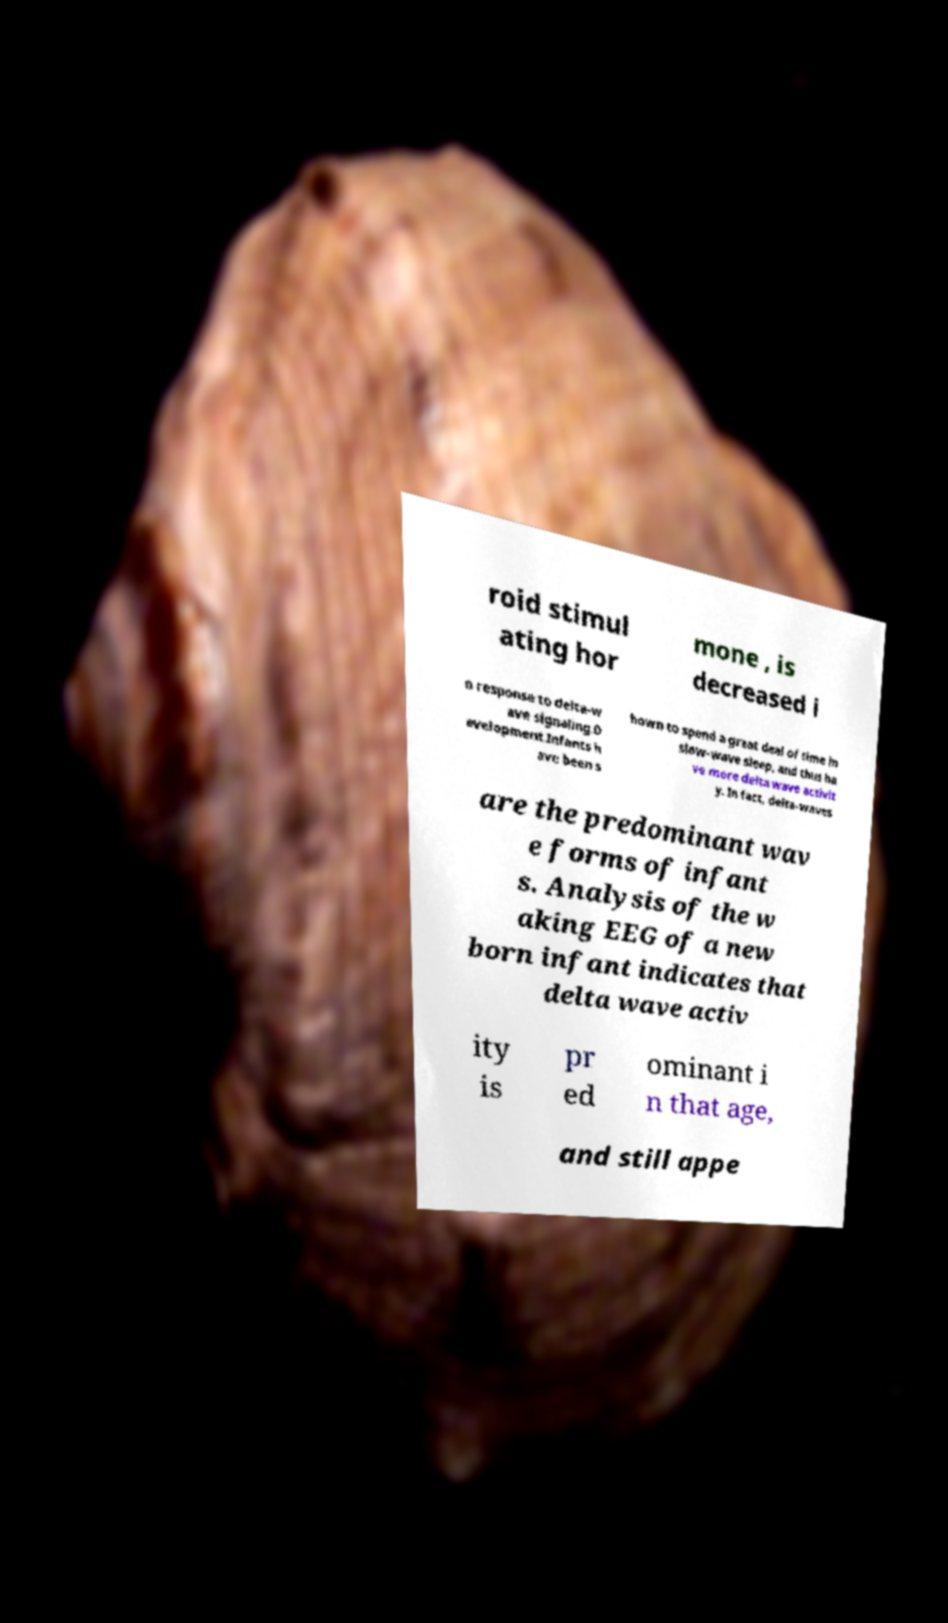There's text embedded in this image that I need extracted. Can you transcribe it verbatim? roid stimul ating hor mone , is decreased i n response to delta-w ave signaling.D evelopment.Infants h ave been s hown to spend a great deal of time in slow-wave sleep, and thus ha ve more delta wave activit y. In fact, delta-waves are the predominant wav e forms of infant s. Analysis of the w aking EEG of a new born infant indicates that delta wave activ ity is pr ed ominant i n that age, and still appe 